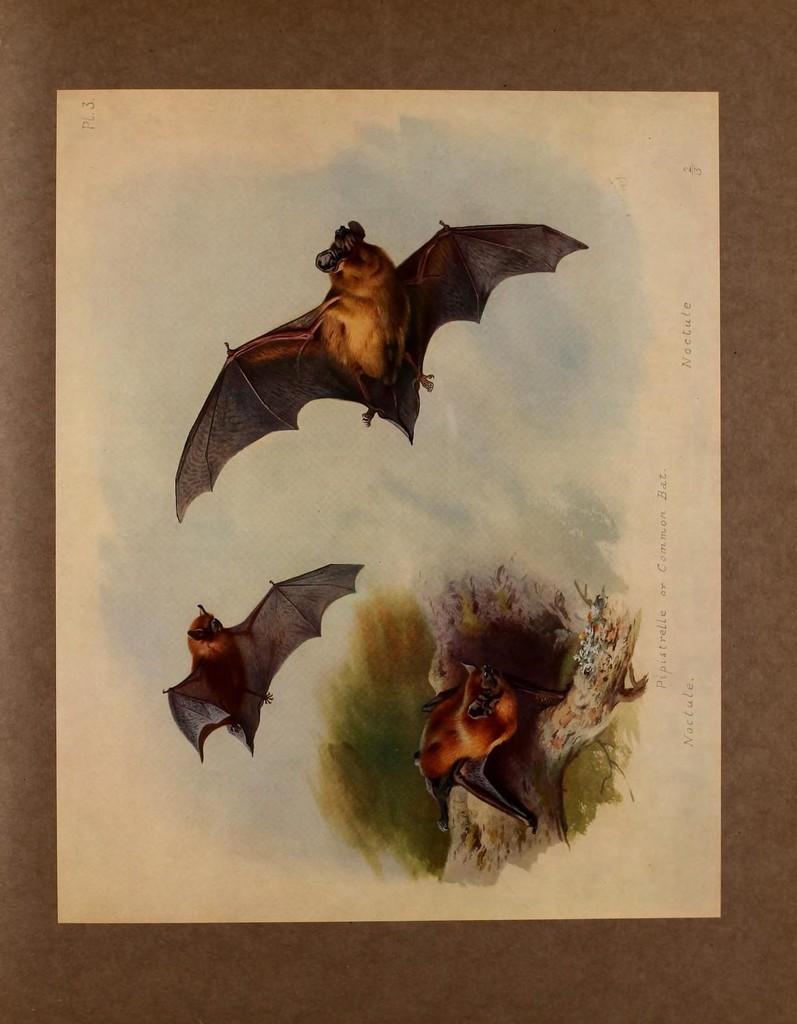Could you give a brief overview of what you see in this image? The picture is a painting. In the picture there are bats and trunk of a tree. The picture has a brown border. 